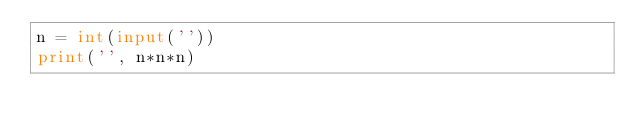Convert code to text. <code><loc_0><loc_0><loc_500><loc_500><_Python_>n = int(input(''))
print('', n*n*n)
</code> 